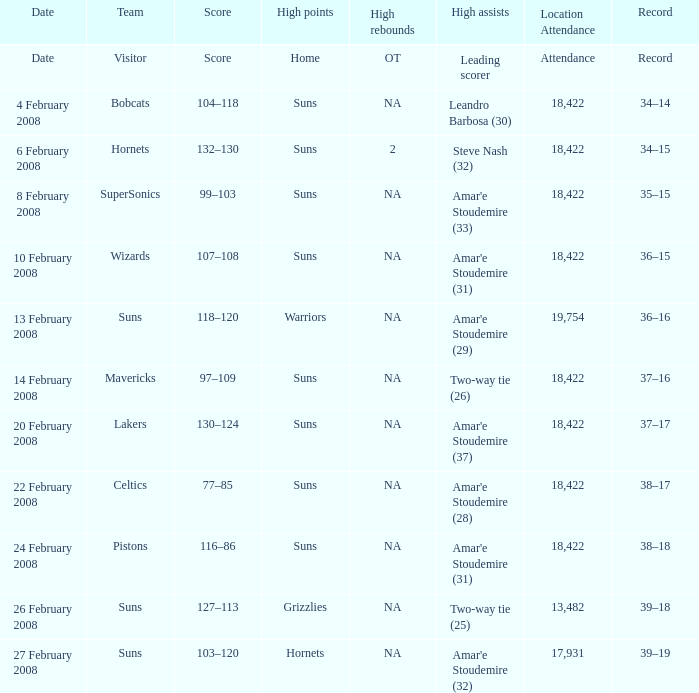What was the number of high assists for the lakers? Amar'e Stoudemire (37). 